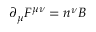Convert formula to latex. <formula><loc_0><loc_0><loc_500><loc_500>{ \partial } _ { \mu } F ^ { { \mu } { \nu } } = n ^ { \nu } B</formula> 